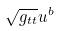Convert formula to latex. <formula><loc_0><loc_0><loc_500><loc_500>\sqrt { g _ { t t } } u ^ { b }</formula> 